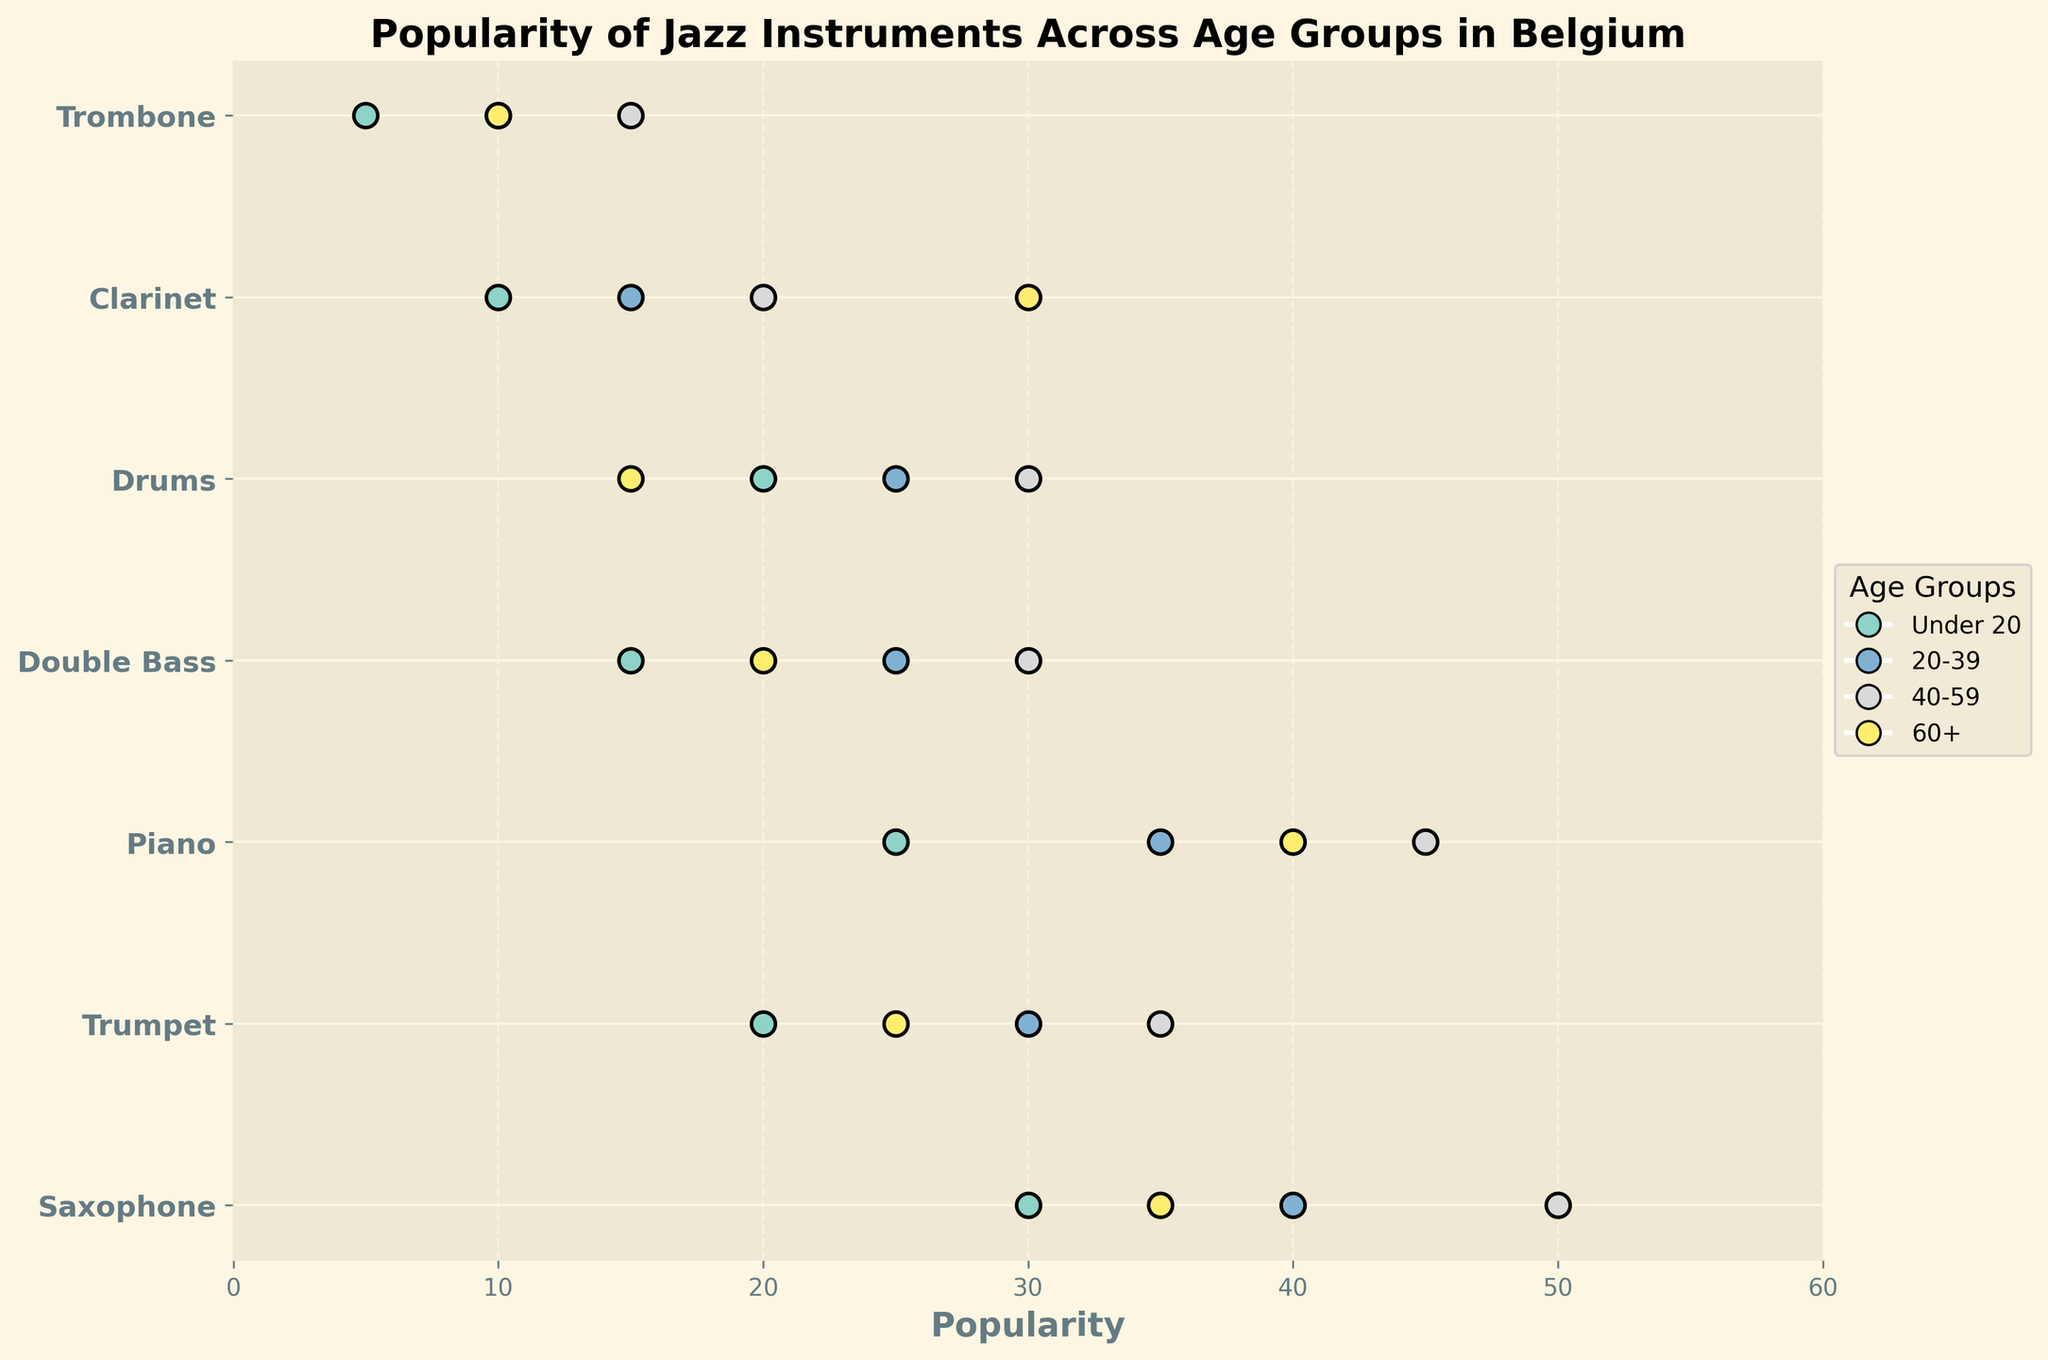Which instrument is the most popular among the 40-59 age group? To determine the most popular instrument among the 40-59 age group, look for the highest popularity dot among this age group. The Saxophone has a popularity of 50 in this age group, which is the highest.
Answer: Saxophone What is the least popular instrument among people under 20? To identify the least popular instrument for the under-20 age group, find the lowest popularity value among the dots for this age group. The Trombone is least popular, with a popularity of 5.
Answer: Trombone How does the popularity of the Piano change across the different age groups? To understand how the popularity of the Piano changes, look at the position of Piano's dots in each age group: Under 20 is 25, 20-39 is 35, 40-59 is 45, and 60+ is 40. This indicates a general increase in popularity, reaching a peak and slightly dropping in the 60+ group.
Answer: Generally increases, peaks at 45, then slightly drops to 40 Which age group has the highest popularity for the Clarinet? Check the Clarinet's dots to see which one is the highest. The popularity for 60+ is 30, the highest among all age groups for the Clarinet.
Answer: 60+ How many instruments have a popularity of 30 or more among the 40-59 age group? Count the dots in the 40-59 age group with a popularity of 30 or more: Saxophone (50), Trumpet (35), Piano (45), Double Bass (30), Drums (30), and Clarinet (20). There are five instruments meeting this criterion.
Answer: 5 What is the difference in popularity of the Drums between the Under 20 and 60+ age groups? Look at the popularity values of the Drums for Under 20 (20) and 60+ (15), then subtract the latter from the former. The difference is 20 - 15 = 5.
Answer: 5 Between the Trumpet and Double Bass, which is more popular among the 20-39 age group? Compare the popularity values for the two instruments in the 20-39 age group: Trumpet (30) and Double Bass (25). The Trumpet is more popular.
Answer: Trumpet Does any instrument maintain a stable popularity across all age groups? Scan through the instruments to check if any have similar popularity values across all age groups. None of the instruments show a stable popularity across all age groups; each has noticeable changes.
Answer: No What is the average popularity of the Saxophone across all age groups? Add up the popularity values for the Saxophone (30 + 40 + 50 + 35) and divide by the number of age groups (4). (30 + 40 + 50 + 35) / 4 = 155 / 4 = 38.75
Answer: 38.75 